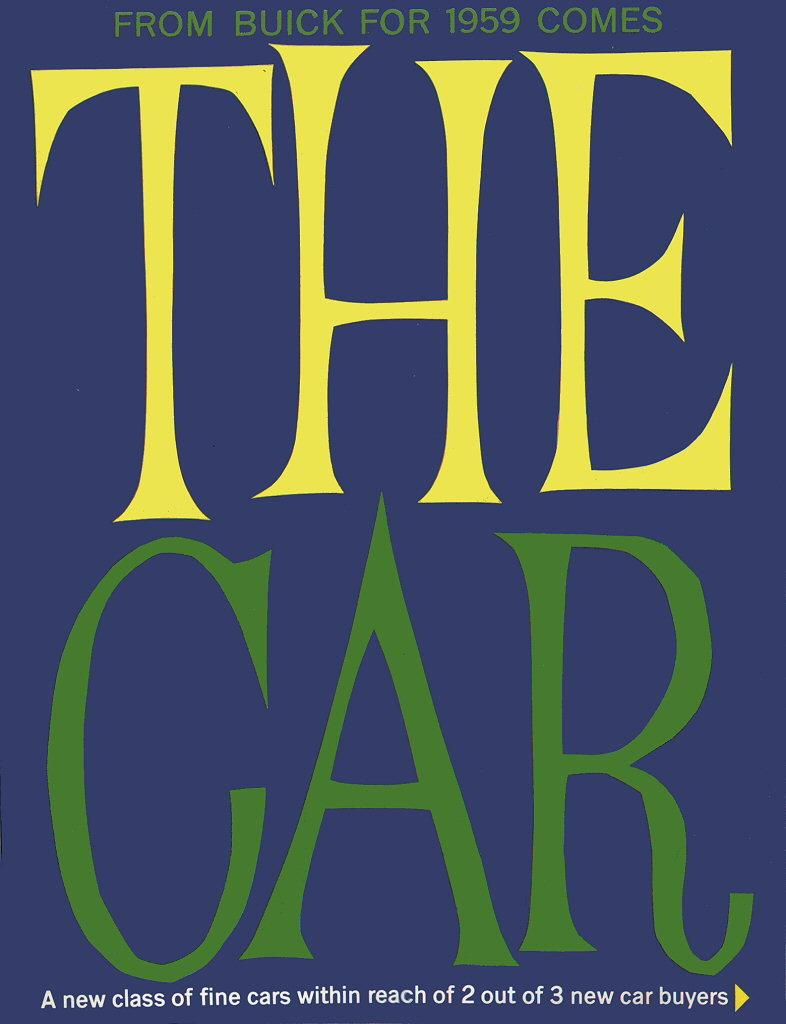<image>
Describe the image concisely. a book cover for the book 'the car' 